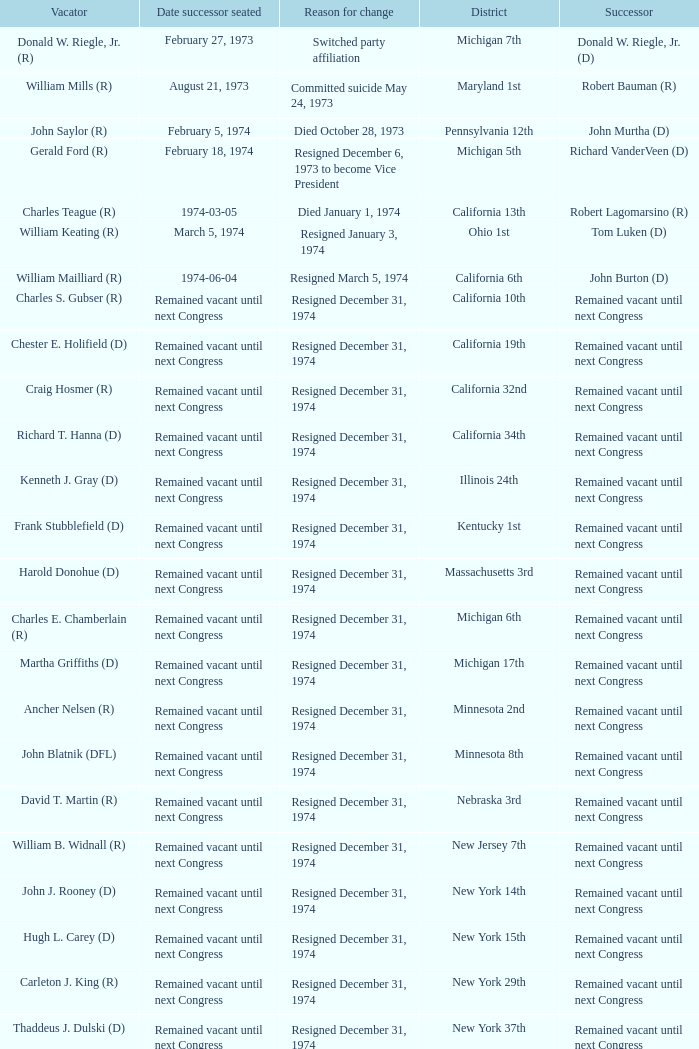Who was the vacator when the date successor seated was august 21, 1973? William Mills (R). 